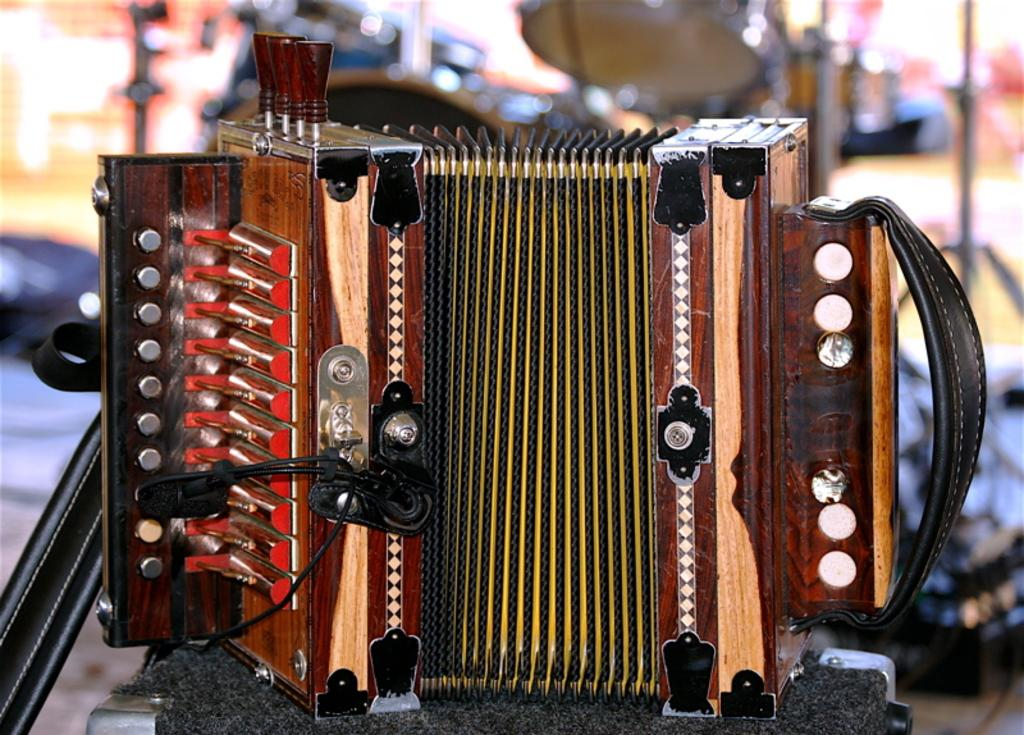What is the main object in the image? There is an accordion in the image. Where is the accordion placed? The accordion is on a surface. What other objects are present in the image? There are other instruments in the image. Can you describe the background of the image? The background of the image is blurred. What type of lettuce is being used to play the accordion in the image? There is no lettuce present in the image, and the accordion is not being played with any lettuce. 